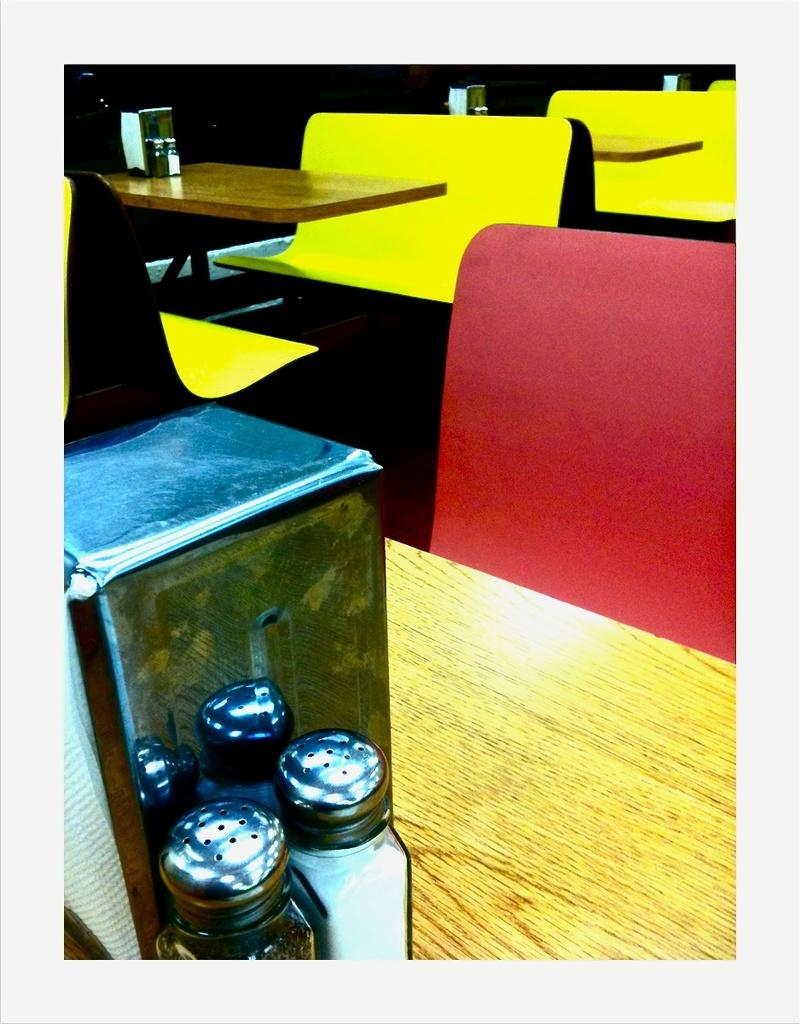What type of containers are located at the bottom of the image? There are ingredient glass jars at the bottom of the image. What type of furniture is at the top of the image? There are sitting benches at the top of the image. What type of furniture is in the middle of the image? There are dining tables in the middle of the image. Can you see a frog sitting on one of the dining tables in the image? No, there is no frog present in the image. What type of treatment is being administered to the sitting benches in the image? There is no treatment being administered to the sitting benches in the image; they are simply furniture. 